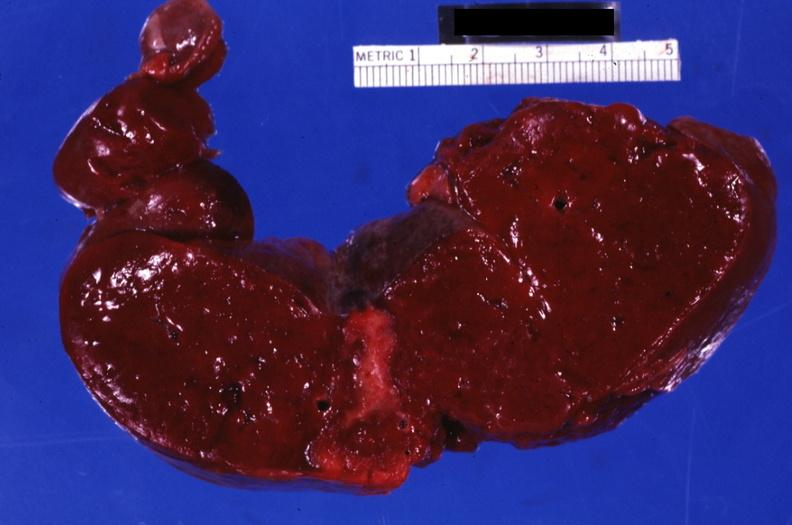what is section through spleen with large shown?
Answer the question using a single word or phrase. Shown healing infarct 